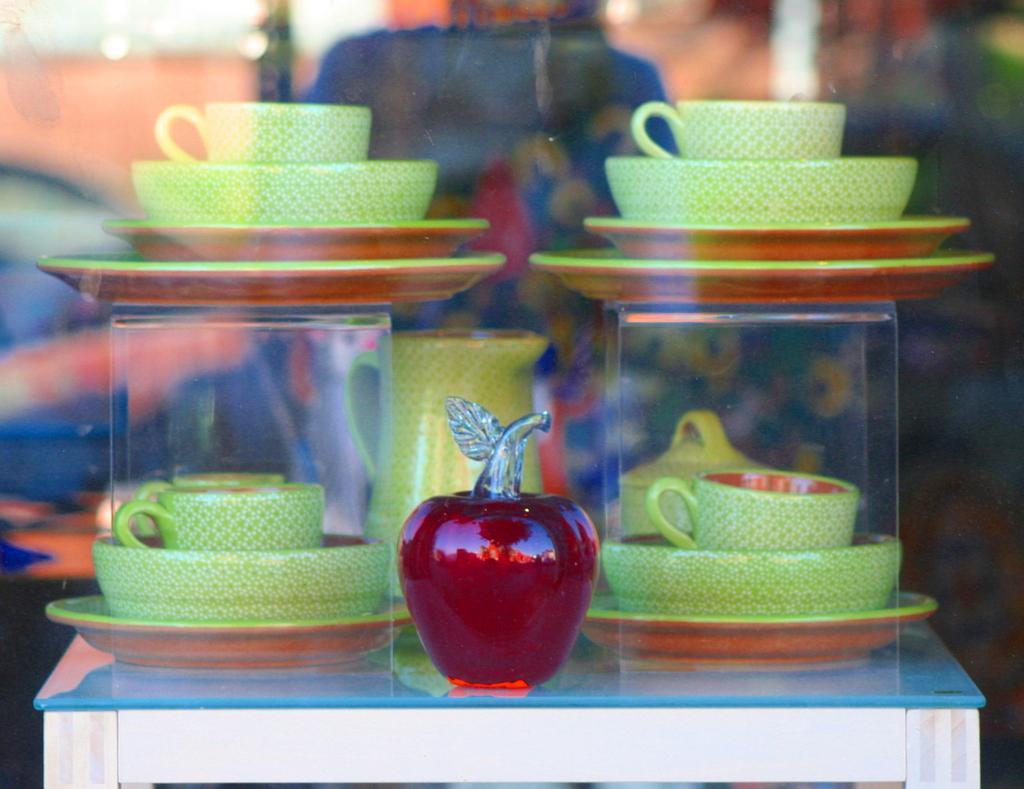In one or two sentences, can you explain what this image depicts? In this image we can see few cups, bowls, plates, a jug and an object on the table and a blurry background. 